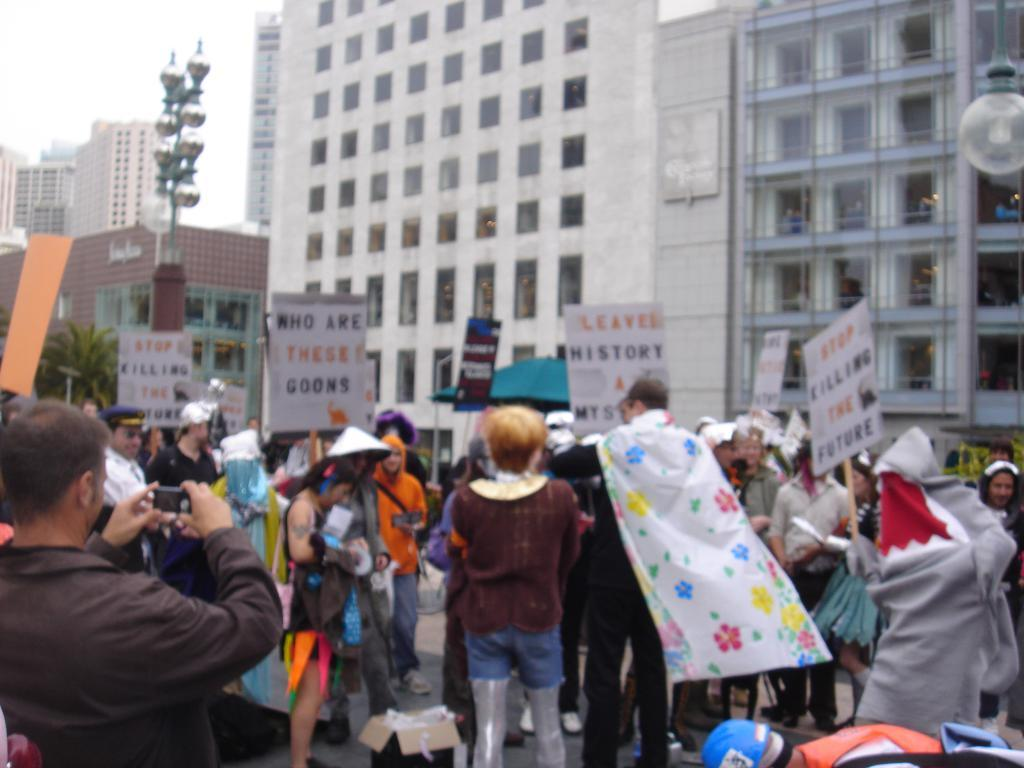How many people can be seen in the image? There are people in the image, but the exact number is not specified. What object is made of cardboard in the image? There is a cardboard box in the image. What type of objects are present in the image? There are boards and lights visible in the image. What is the pole used for in the image? The purpose of the pole is not specified in the image. What can be seen in the background of the image? There are buildings, a tree, and the sky visible in the background of the image. Is there a flame visible on the pole in the image? There is no flame visible on the pole in the image. Are the people in the image engaged in a fight? There is no indication of a fight or any conflict between the people in the image. 